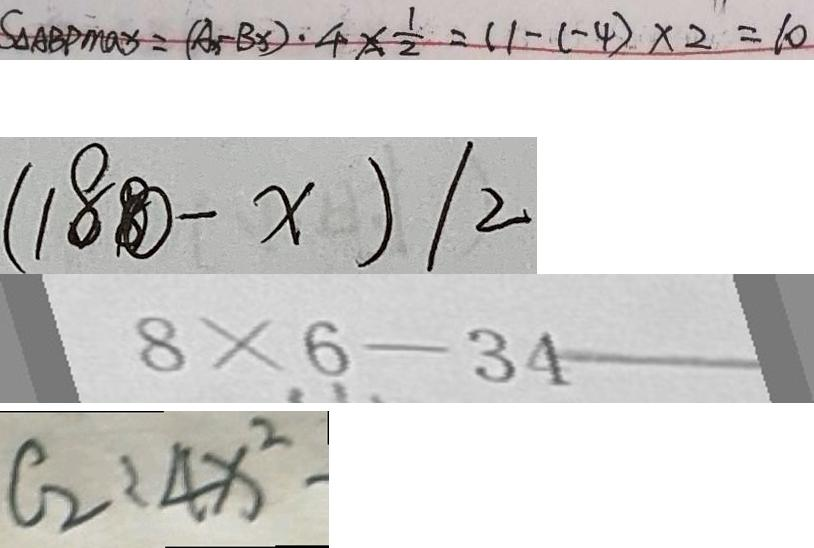<formula> <loc_0><loc_0><loc_500><loc_500>S _ { \Delta A B P \max } = ( A _ { x } - B _ { x } ) \cdot 4 \times \frac { 1 } { 2 } = ( 1 - ( - 4 ) \times 2 = 1 0 
 ( 1 8 - x ) / 2 
 8 \times 6 - 3 4 
 C _ { 2 } : 4 x ^ { 2 } -</formula> 